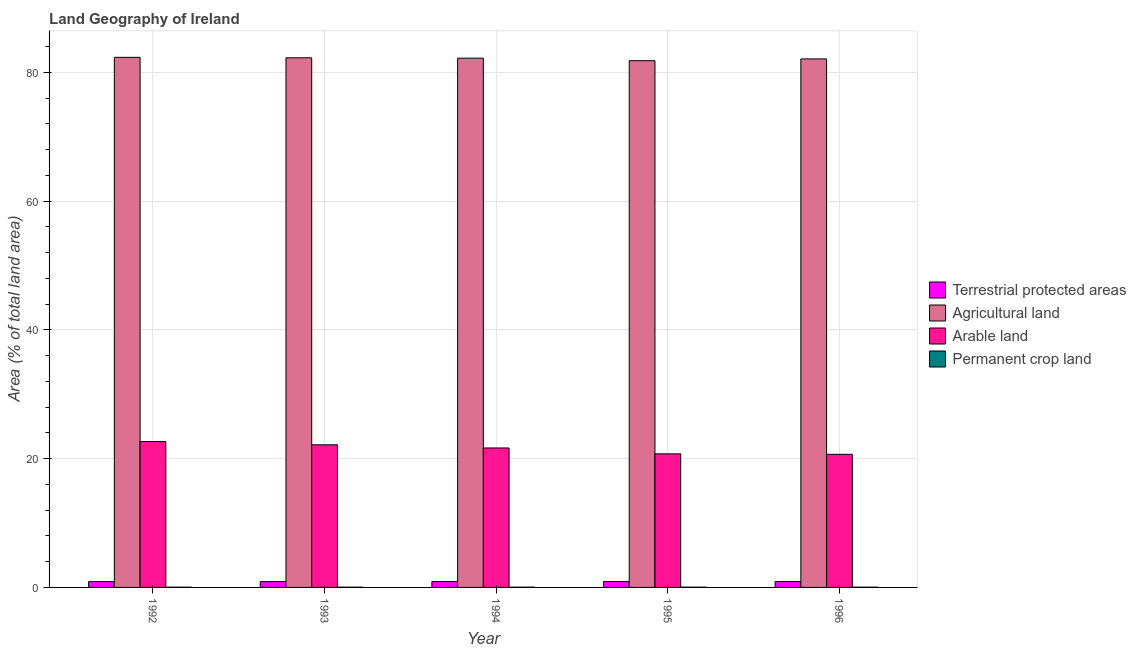Are the number of bars on each tick of the X-axis equal?
Your answer should be very brief. Yes. How many bars are there on the 2nd tick from the left?
Ensure brevity in your answer.  4. How many bars are there on the 3rd tick from the right?
Your answer should be very brief. 4. What is the label of the 3rd group of bars from the left?
Offer a very short reply. 1994. What is the percentage of area under arable land in 1995?
Your answer should be very brief. 20.74. Across all years, what is the maximum percentage of area under arable land?
Keep it short and to the point. 22.66. Across all years, what is the minimum percentage of area under agricultural land?
Make the answer very short. 81.8. In which year was the percentage of area under arable land maximum?
Provide a short and direct response. 1992. In which year was the percentage of area under arable land minimum?
Make the answer very short. 1996. What is the total percentage of area under arable land in the graph?
Provide a succinct answer. 107.88. What is the difference between the percentage of area under agricultural land in 1992 and that in 1994?
Ensure brevity in your answer.  0.13. What is the difference between the percentage of area under arable land in 1995 and the percentage of area under agricultural land in 1994?
Your response must be concise. -0.91. What is the average percentage of area under agricultural land per year?
Your answer should be compact. 82.13. What is the ratio of the percentage of area under arable land in 1992 to that in 1995?
Make the answer very short. 1.09. Is the percentage of area under arable land in 1992 less than that in 1995?
Provide a succinct answer. No. Is the difference between the percentage of area under permanent crop land in 1993 and 1996 greater than the difference between the percentage of land under terrestrial protection in 1993 and 1996?
Keep it short and to the point. No. What is the difference between the highest and the second highest percentage of area under agricultural land?
Your answer should be compact. 0.07. What is the difference between the highest and the lowest percentage of area under arable land?
Your response must be concise. 1.99. In how many years, is the percentage of area under permanent crop land greater than the average percentage of area under permanent crop land taken over all years?
Your answer should be compact. 0. Is it the case that in every year, the sum of the percentage of area under agricultural land and percentage of area under arable land is greater than the sum of percentage of land under terrestrial protection and percentage of area under permanent crop land?
Offer a terse response. Yes. What does the 3rd bar from the left in 1996 represents?
Provide a short and direct response. Arable land. What does the 4th bar from the right in 1992 represents?
Give a very brief answer. Terrestrial protected areas. Are all the bars in the graph horizontal?
Provide a succinct answer. No. How many years are there in the graph?
Keep it short and to the point. 5. What is the difference between two consecutive major ticks on the Y-axis?
Provide a short and direct response. 20. Are the values on the major ticks of Y-axis written in scientific E-notation?
Your answer should be compact. No. Does the graph contain any zero values?
Offer a very short reply. No. Does the graph contain grids?
Your answer should be compact. Yes. Where does the legend appear in the graph?
Provide a short and direct response. Center right. How are the legend labels stacked?
Give a very brief answer. Vertical. What is the title of the graph?
Offer a very short reply. Land Geography of Ireland. What is the label or title of the X-axis?
Your response must be concise. Year. What is the label or title of the Y-axis?
Offer a very short reply. Area (% of total land area). What is the Area (% of total land area) of Terrestrial protected areas in 1992?
Offer a very short reply. 0.9. What is the Area (% of total land area) of Agricultural land in 1992?
Provide a short and direct response. 82.32. What is the Area (% of total land area) of Arable land in 1992?
Your response must be concise. 22.66. What is the Area (% of total land area) in Permanent crop land in 1992?
Keep it short and to the point. 0.04. What is the Area (% of total land area) in Terrestrial protected areas in 1993?
Provide a short and direct response. 0.9. What is the Area (% of total land area) in Agricultural land in 1993?
Your answer should be compact. 82.25. What is the Area (% of total land area) in Arable land in 1993?
Keep it short and to the point. 22.15. What is the Area (% of total land area) of Permanent crop land in 1993?
Ensure brevity in your answer.  0.04. What is the Area (% of total land area) of Terrestrial protected areas in 1994?
Make the answer very short. 0.91. What is the Area (% of total land area) of Agricultural land in 1994?
Offer a terse response. 82.19. What is the Area (% of total land area) in Arable land in 1994?
Make the answer very short. 21.66. What is the Area (% of total land area) in Permanent crop land in 1994?
Keep it short and to the point. 0.04. What is the Area (% of total land area) of Terrestrial protected areas in 1995?
Ensure brevity in your answer.  0.91. What is the Area (% of total land area) in Agricultural land in 1995?
Give a very brief answer. 81.8. What is the Area (% of total land area) of Arable land in 1995?
Give a very brief answer. 20.74. What is the Area (% of total land area) of Permanent crop land in 1995?
Provide a succinct answer. 0.04. What is the Area (% of total land area) of Terrestrial protected areas in 1996?
Make the answer very short. 0.91. What is the Area (% of total land area) in Agricultural land in 1996?
Your answer should be very brief. 82.07. What is the Area (% of total land area) of Arable land in 1996?
Give a very brief answer. 20.67. What is the Area (% of total land area) in Permanent crop land in 1996?
Your answer should be very brief. 0.04. Across all years, what is the maximum Area (% of total land area) of Terrestrial protected areas?
Offer a terse response. 0.91. Across all years, what is the maximum Area (% of total land area) of Agricultural land?
Your answer should be compact. 82.32. Across all years, what is the maximum Area (% of total land area) in Arable land?
Provide a succinct answer. 22.66. Across all years, what is the maximum Area (% of total land area) of Permanent crop land?
Your response must be concise. 0.04. Across all years, what is the minimum Area (% of total land area) of Terrestrial protected areas?
Ensure brevity in your answer.  0.9. Across all years, what is the minimum Area (% of total land area) of Agricultural land?
Your answer should be compact. 81.8. Across all years, what is the minimum Area (% of total land area) in Arable land?
Keep it short and to the point. 20.67. Across all years, what is the minimum Area (% of total land area) in Permanent crop land?
Your response must be concise. 0.04. What is the total Area (% of total land area) of Terrestrial protected areas in the graph?
Your answer should be very brief. 4.53. What is the total Area (% of total land area) of Agricultural land in the graph?
Provide a succinct answer. 410.63. What is the total Area (% of total land area) of Arable land in the graph?
Your answer should be very brief. 107.88. What is the total Area (% of total land area) of Permanent crop land in the graph?
Provide a succinct answer. 0.22. What is the difference between the Area (% of total land area) of Terrestrial protected areas in 1992 and that in 1993?
Keep it short and to the point. -0. What is the difference between the Area (% of total land area) in Agricultural land in 1992 and that in 1993?
Your answer should be very brief. 0.07. What is the difference between the Area (% of total land area) in Arable land in 1992 and that in 1993?
Provide a succinct answer. 0.51. What is the difference between the Area (% of total land area) in Permanent crop land in 1992 and that in 1993?
Make the answer very short. 0. What is the difference between the Area (% of total land area) of Terrestrial protected areas in 1992 and that in 1994?
Your response must be concise. -0. What is the difference between the Area (% of total land area) of Agricultural land in 1992 and that in 1994?
Offer a very short reply. 0.13. What is the difference between the Area (% of total land area) of Permanent crop land in 1992 and that in 1994?
Your response must be concise. 0. What is the difference between the Area (% of total land area) in Terrestrial protected areas in 1992 and that in 1995?
Your answer should be compact. -0.01. What is the difference between the Area (% of total land area) of Agricultural land in 1992 and that in 1995?
Your answer should be very brief. 0.52. What is the difference between the Area (% of total land area) in Arable land in 1992 and that in 1995?
Make the answer very short. 1.92. What is the difference between the Area (% of total land area) in Terrestrial protected areas in 1992 and that in 1996?
Your answer should be compact. -0.01. What is the difference between the Area (% of total land area) of Agricultural land in 1992 and that in 1996?
Ensure brevity in your answer.  0.25. What is the difference between the Area (% of total land area) of Arable land in 1992 and that in 1996?
Your answer should be compact. 1.99. What is the difference between the Area (% of total land area) of Terrestrial protected areas in 1993 and that in 1994?
Ensure brevity in your answer.  -0. What is the difference between the Area (% of total land area) of Agricultural land in 1993 and that in 1994?
Your answer should be very brief. 0.06. What is the difference between the Area (% of total land area) of Arable land in 1993 and that in 1994?
Ensure brevity in your answer.  0.49. What is the difference between the Area (% of total land area) in Permanent crop land in 1993 and that in 1994?
Ensure brevity in your answer.  0. What is the difference between the Area (% of total land area) of Terrestrial protected areas in 1993 and that in 1995?
Your answer should be compact. -0. What is the difference between the Area (% of total land area) in Agricultural land in 1993 and that in 1995?
Make the answer very short. 0.45. What is the difference between the Area (% of total land area) in Arable land in 1993 and that in 1995?
Offer a terse response. 1.41. What is the difference between the Area (% of total land area) in Terrestrial protected areas in 1993 and that in 1996?
Give a very brief answer. -0.01. What is the difference between the Area (% of total land area) in Agricultural land in 1993 and that in 1996?
Offer a very short reply. 0.17. What is the difference between the Area (% of total land area) of Arable land in 1993 and that in 1996?
Your answer should be very brief. 1.48. What is the difference between the Area (% of total land area) of Permanent crop land in 1993 and that in 1996?
Offer a terse response. 0. What is the difference between the Area (% of total land area) of Terrestrial protected areas in 1994 and that in 1995?
Offer a very short reply. -0. What is the difference between the Area (% of total land area) in Agricultural land in 1994 and that in 1995?
Offer a terse response. 0.39. What is the difference between the Area (% of total land area) of Arable land in 1994 and that in 1995?
Ensure brevity in your answer.  0.91. What is the difference between the Area (% of total land area) in Terrestrial protected areas in 1994 and that in 1996?
Your response must be concise. -0. What is the difference between the Area (% of total land area) of Agricultural land in 1994 and that in 1996?
Provide a short and direct response. 0.12. What is the difference between the Area (% of total land area) in Arable land in 1994 and that in 1996?
Keep it short and to the point. 0.99. What is the difference between the Area (% of total land area) in Permanent crop land in 1994 and that in 1996?
Keep it short and to the point. 0. What is the difference between the Area (% of total land area) of Terrestrial protected areas in 1995 and that in 1996?
Offer a terse response. -0. What is the difference between the Area (% of total land area) in Agricultural land in 1995 and that in 1996?
Provide a succinct answer. -0.28. What is the difference between the Area (% of total land area) in Arable land in 1995 and that in 1996?
Provide a succinct answer. 0.07. What is the difference between the Area (% of total land area) of Permanent crop land in 1995 and that in 1996?
Provide a succinct answer. 0. What is the difference between the Area (% of total land area) of Terrestrial protected areas in 1992 and the Area (% of total land area) of Agricultural land in 1993?
Offer a terse response. -81.34. What is the difference between the Area (% of total land area) in Terrestrial protected areas in 1992 and the Area (% of total land area) in Arable land in 1993?
Offer a very short reply. -21.25. What is the difference between the Area (% of total land area) in Terrestrial protected areas in 1992 and the Area (% of total land area) in Permanent crop land in 1993?
Provide a short and direct response. 0.86. What is the difference between the Area (% of total land area) in Agricultural land in 1992 and the Area (% of total land area) in Arable land in 1993?
Your response must be concise. 60.17. What is the difference between the Area (% of total land area) in Agricultural land in 1992 and the Area (% of total land area) in Permanent crop land in 1993?
Offer a terse response. 82.28. What is the difference between the Area (% of total land area) of Arable land in 1992 and the Area (% of total land area) of Permanent crop land in 1993?
Make the answer very short. 22.62. What is the difference between the Area (% of total land area) in Terrestrial protected areas in 1992 and the Area (% of total land area) in Agricultural land in 1994?
Offer a terse response. -81.29. What is the difference between the Area (% of total land area) of Terrestrial protected areas in 1992 and the Area (% of total land area) of Arable land in 1994?
Your answer should be compact. -20.76. What is the difference between the Area (% of total land area) in Terrestrial protected areas in 1992 and the Area (% of total land area) in Permanent crop land in 1994?
Give a very brief answer. 0.86. What is the difference between the Area (% of total land area) of Agricultural land in 1992 and the Area (% of total land area) of Arable land in 1994?
Offer a terse response. 60.66. What is the difference between the Area (% of total land area) of Agricultural land in 1992 and the Area (% of total land area) of Permanent crop land in 1994?
Ensure brevity in your answer.  82.28. What is the difference between the Area (% of total land area) of Arable land in 1992 and the Area (% of total land area) of Permanent crop land in 1994?
Make the answer very short. 22.62. What is the difference between the Area (% of total land area) in Terrestrial protected areas in 1992 and the Area (% of total land area) in Agricultural land in 1995?
Ensure brevity in your answer.  -80.89. What is the difference between the Area (% of total land area) of Terrestrial protected areas in 1992 and the Area (% of total land area) of Arable land in 1995?
Your response must be concise. -19.84. What is the difference between the Area (% of total land area) in Terrestrial protected areas in 1992 and the Area (% of total land area) in Permanent crop land in 1995?
Provide a short and direct response. 0.86. What is the difference between the Area (% of total land area) in Agricultural land in 1992 and the Area (% of total land area) in Arable land in 1995?
Make the answer very short. 61.58. What is the difference between the Area (% of total land area) of Agricultural land in 1992 and the Area (% of total land area) of Permanent crop land in 1995?
Provide a short and direct response. 82.28. What is the difference between the Area (% of total land area) in Arable land in 1992 and the Area (% of total land area) in Permanent crop land in 1995?
Provide a short and direct response. 22.62. What is the difference between the Area (% of total land area) in Terrestrial protected areas in 1992 and the Area (% of total land area) in Agricultural land in 1996?
Offer a terse response. -81.17. What is the difference between the Area (% of total land area) of Terrestrial protected areas in 1992 and the Area (% of total land area) of Arable land in 1996?
Provide a short and direct response. -19.77. What is the difference between the Area (% of total land area) in Terrestrial protected areas in 1992 and the Area (% of total land area) in Permanent crop land in 1996?
Your response must be concise. 0.86. What is the difference between the Area (% of total land area) in Agricultural land in 1992 and the Area (% of total land area) in Arable land in 1996?
Ensure brevity in your answer.  61.65. What is the difference between the Area (% of total land area) of Agricultural land in 1992 and the Area (% of total land area) of Permanent crop land in 1996?
Give a very brief answer. 82.28. What is the difference between the Area (% of total land area) in Arable land in 1992 and the Area (% of total land area) in Permanent crop land in 1996?
Keep it short and to the point. 22.62. What is the difference between the Area (% of total land area) in Terrestrial protected areas in 1993 and the Area (% of total land area) in Agricultural land in 1994?
Offer a very short reply. -81.29. What is the difference between the Area (% of total land area) of Terrestrial protected areas in 1993 and the Area (% of total land area) of Arable land in 1994?
Give a very brief answer. -20.75. What is the difference between the Area (% of total land area) in Terrestrial protected areas in 1993 and the Area (% of total land area) in Permanent crop land in 1994?
Offer a very short reply. 0.86. What is the difference between the Area (% of total land area) of Agricultural land in 1993 and the Area (% of total land area) of Arable land in 1994?
Ensure brevity in your answer.  60.59. What is the difference between the Area (% of total land area) in Agricultural land in 1993 and the Area (% of total land area) in Permanent crop land in 1994?
Your response must be concise. 82.2. What is the difference between the Area (% of total land area) in Arable land in 1993 and the Area (% of total land area) in Permanent crop land in 1994?
Your answer should be compact. 22.11. What is the difference between the Area (% of total land area) of Terrestrial protected areas in 1993 and the Area (% of total land area) of Agricultural land in 1995?
Your response must be concise. -80.89. What is the difference between the Area (% of total land area) in Terrestrial protected areas in 1993 and the Area (% of total land area) in Arable land in 1995?
Your answer should be very brief. -19.84. What is the difference between the Area (% of total land area) of Terrestrial protected areas in 1993 and the Area (% of total land area) of Permanent crop land in 1995?
Your answer should be compact. 0.86. What is the difference between the Area (% of total land area) of Agricultural land in 1993 and the Area (% of total land area) of Arable land in 1995?
Your answer should be very brief. 61.5. What is the difference between the Area (% of total land area) of Agricultural land in 1993 and the Area (% of total land area) of Permanent crop land in 1995?
Make the answer very short. 82.2. What is the difference between the Area (% of total land area) of Arable land in 1993 and the Area (% of total land area) of Permanent crop land in 1995?
Give a very brief answer. 22.11. What is the difference between the Area (% of total land area) in Terrestrial protected areas in 1993 and the Area (% of total land area) in Agricultural land in 1996?
Give a very brief answer. -81.17. What is the difference between the Area (% of total land area) in Terrestrial protected areas in 1993 and the Area (% of total land area) in Arable land in 1996?
Offer a very short reply. -19.77. What is the difference between the Area (% of total land area) of Terrestrial protected areas in 1993 and the Area (% of total land area) of Permanent crop land in 1996?
Offer a very short reply. 0.86. What is the difference between the Area (% of total land area) in Agricultural land in 1993 and the Area (% of total land area) in Arable land in 1996?
Keep it short and to the point. 61.58. What is the difference between the Area (% of total land area) of Agricultural land in 1993 and the Area (% of total land area) of Permanent crop land in 1996?
Ensure brevity in your answer.  82.2. What is the difference between the Area (% of total land area) in Arable land in 1993 and the Area (% of total land area) in Permanent crop land in 1996?
Provide a short and direct response. 22.11. What is the difference between the Area (% of total land area) of Terrestrial protected areas in 1994 and the Area (% of total land area) of Agricultural land in 1995?
Provide a succinct answer. -80.89. What is the difference between the Area (% of total land area) in Terrestrial protected areas in 1994 and the Area (% of total land area) in Arable land in 1995?
Provide a succinct answer. -19.84. What is the difference between the Area (% of total land area) in Terrestrial protected areas in 1994 and the Area (% of total land area) in Permanent crop land in 1995?
Offer a very short reply. 0.86. What is the difference between the Area (% of total land area) of Agricultural land in 1994 and the Area (% of total land area) of Arable land in 1995?
Offer a terse response. 61.45. What is the difference between the Area (% of total land area) in Agricultural land in 1994 and the Area (% of total land area) in Permanent crop land in 1995?
Your answer should be compact. 82.15. What is the difference between the Area (% of total land area) in Arable land in 1994 and the Area (% of total land area) in Permanent crop land in 1995?
Offer a very short reply. 21.61. What is the difference between the Area (% of total land area) in Terrestrial protected areas in 1994 and the Area (% of total land area) in Agricultural land in 1996?
Keep it short and to the point. -81.17. What is the difference between the Area (% of total land area) of Terrestrial protected areas in 1994 and the Area (% of total land area) of Arable land in 1996?
Your answer should be compact. -19.76. What is the difference between the Area (% of total land area) of Terrestrial protected areas in 1994 and the Area (% of total land area) of Permanent crop land in 1996?
Provide a short and direct response. 0.86. What is the difference between the Area (% of total land area) of Agricultural land in 1994 and the Area (% of total land area) of Arable land in 1996?
Provide a succinct answer. 61.52. What is the difference between the Area (% of total land area) of Agricultural land in 1994 and the Area (% of total land area) of Permanent crop land in 1996?
Your answer should be compact. 82.15. What is the difference between the Area (% of total land area) of Arable land in 1994 and the Area (% of total land area) of Permanent crop land in 1996?
Ensure brevity in your answer.  21.61. What is the difference between the Area (% of total land area) of Terrestrial protected areas in 1995 and the Area (% of total land area) of Agricultural land in 1996?
Keep it short and to the point. -81.17. What is the difference between the Area (% of total land area) of Terrestrial protected areas in 1995 and the Area (% of total land area) of Arable land in 1996?
Your response must be concise. -19.76. What is the difference between the Area (% of total land area) of Terrestrial protected areas in 1995 and the Area (% of total land area) of Permanent crop land in 1996?
Your answer should be very brief. 0.86. What is the difference between the Area (% of total land area) in Agricultural land in 1995 and the Area (% of total land area) in Arable land in 1996?
Ensure brevity in your answer.  61.13. What is the difference between the Area (% of total land area) of Agricultural land in 1995 and the Area (% of total land area) of Permanent crop land in 1996?
Your answer should be very brief. 81.75. What is the difference between the Area (% of total land area) in Arable land in 1995 and the Area (% of total land area) in Permanent crop land in 1996?
Make the answer very short. 20.7. What is the average Area (% of total land area) of Terrestrial protected areas per year?
Offer a terse response. 0.91. What is the average Area (% of total land area) of Agricultural land per year?
Your response must be concise. 82.13. What is the average Area (% of total land area) in Arable land per year?
Ensure brevity in your answer.  21.58. What is the average Area (% of total land area) in Permanent crop land per year?
Offer a very short reply. 0.04. In the year 1992, what is the difference between the Area (% of total land area) of Terrestrial protected areas and Area (% of total land area) of Agricultural land?
Offer a terse response. -81.42. In the year 1992, what is the difference between the Area (% of total land area) in Terrestrial protected areas and Area (% of total land area) in Arable land?
Provide a short and direct response. -21.76. In the year 1992, what is the difference between the Area (% of total land area) in Terrestrial protected areas and Area (% of total land area) in Permanent crop land?
Make the answer very short. 0.86. In the year 1992, what is the difference between the Area (% of total land area) of Agricultural land and Area (% of total land area) of Arable land?
Offer a very short reply. 59.66. In the year 1992, what is the difference between the Area (% of total land area) of Agricultural land and Area (% of total land area) of Permanent crop land?
Give a very brief answer. 82.28. In the year 1992, what is the difference between the Area (% of total land area) in Arable land and Area (% of total land area) in Permanent crop land?
Make the answer very short. 22.62. In the year 1993, what is the difference between the Area (% of total land area) of Terrestrial protected areas and Area (% of total land area) of Agricultural land?
Your response must be concise. -81.34. In the year 1993, what is the difference between the Area (% of total land area) in Terrestrial protected areas and Area (% of total land area) in Arable land?
Your response must be concise. -21.25. In the year 1993, what is the difference between the Area (% of total land area) of Terrestrial protected areas and Area (% of total land area) of Permanent crop land?
Make the answer very short. 0.86. In the year 1993, what is the difference between the Area (% of total land area) in Agricultural land and Area (% of total land area) in Arable land?
Keep it short and to the point. 60.1. In the year 1993, what is the difference between the Area (% of total land area) of Agricultural land and Area (% of total land area) of Permanent crop land?
Ensure brevity in your answer.  82.2. In the year 1993, what is the difference between the Area (% of total land area) in Arable land and Area (% of total land area) in Permanent crop land?
Make the answer very short. 22.11. In the year 1994, what is the difference between the Area (% of total land area) of Terrestrial protected areas and Area (% of total land area) of Agricultural land?
Give a very brief answer. -81.28. In the year 1994, what is the difference between the Area (% of total land area) in Terrestrial protected areas and Area (% of total land area) in Arable land?
Offer a very short reply. -20.75. In the year 1994, what is the difference between the Area (% of total land area) in Terrestrial protected areas and Area (% of total land area) in Permanent crop land?
Give a very brief answer. 0.86. In the year 1994, what is the difference between the Area (% of total land area) in Agricultural land and Area (% of total land area) in Arable land?
Make the answer very short. 60.53. In the year 1994, what is the difference between the Area (% of total land area) of Agricultural land and Area (% of total land area) of Permanent crop land?
Give a very brief answer. 82.15. In the year 1994, what is the difference between the Area (% of total land area) of Arable land and Area (% of total land area) of Permanent crop land?
Offer a very short reply. 21.61. In the year 1995, what is the difference between the Area (% of total land area) of Terrestrial protected areas and Area (% of total land area) of Agricultural land?
Ensure brevity in your answer.  -80.89. In the year 1995, what is the difference between the Area (% of total land area) in Terrestrial protected areas and Area (% of total land area) in Arable land?
Provide a succinct answer. -19.84. In the year 1995, what is the difference between the Area (% of total land area) in Terrestrial protected areas and Area (% of total land area) in Permanent crop land?
Your response must be concise. 0.86. In the year 1995, what is the difference between the Area (% of total land area) of Agricultural land and Area (% of total land area) of Arable land?
Offer a terse response. 61.05. In the year 1995, what is the difference between the Area (% of total land area) in Agricultural land and Area (% of total land area) in Permanent crop land?
Your response must be concise. 81.75. In the year 1995, what is the difference between the Area (% of total land area) of Arable land and Area (% of total land area) of Permanent crop land?
Provide a succinct answer. 20.7. In the year 1996, what is the difference between the Area (% of total land area) of Terrestrial protected areas and Area (% of total land area) of Agricultural land?
Provide a succinct answer. -81.17. In the year 1996, what is the difference between the Area (% of total land area) in Terrestrial protected areas and Area (% of total land area) in Arable land?
Give a very brief answer. -19.76. In the year 1996, what is the difference between the Area (% of total land area) in Terrestrial protected areas and Area (% of total land area) in Permanent crop land?
Your answer should be compact. 0.86. In the year 1996, what is the difference between the Area (% of total land area) in Agricultural land and Area (% of total land area) in Arable land?
Provide a succinct answer. 61.4. In the year 1996, what is the difference between the Area (% of total land area) of Agricultural land and Area (% of total land area) of Permanent crop land?
Offer a terse response. 82.03. In the year 1996, what is the difference between the Area (% of total land area) in Arable land and Area (% of total land area) in Permanent crop land?
Ensure brevity in your answer.  20.63. What is the ratio of the Area (% of total land area) of Terrestrial protected areas in 1992 to that in 1993?
Offer a very short reply. 1. What is the ratio of the Area (% of total land area) of Agricultural land in 1992 to that in 1993?
Your response must be concise. 1. What is the ratio of the Area (% of total land area) in Arable land in 1992 to that in 1993?
Give a very brief answer. 1.02. What is the ratio of the Area (% of total land area) of Permanent crop land in 1992 to that in 1993?
Keep it short and to the point. 1. What is the ratio of the Area (% of total land area) in Terrestrial protected areas in 1992 to that in 1994?
Ensure brevity in your answer.  1. What is the ratio of the Area (% of total land area) of Arable land in 1992 to that in 1994?
Your answer should be very brief. 1.05. What is the ratio of the Area (% of total land area) of Permanent crop land in 1992 to that in 1994?
Provide a succinct answer. 1. What is the ratio of the Area (% of total land area) in Terrestrial protected areas in 1992 to that in 1995?
Provide a short and direct response. 0.99. What is the ratio of the Area (% of total land area) in Agricultural land in 1992 to that in 1995?
Offer a terse response. 1.01. What is the ratio of the Area (% of total land area) in Arable land in 1992 to that in 1995?
Your answer should be compact. 1.09. What is the ratio of the Area (% of total land area) in Permanent crop land in 1992 to that in 1995?
Keep it short and to the point. 1. What is the ratio of the Area (% of total land area) of Terrestrial protected areas in 1992 to that in 1996?
Give a very brief answer. 0.99. What is the ratio of the Area (% of total land area) in Agricultural land in 1992 to that in 1996?
Give a very brief answer. 1. What is the ratio of the Area (% of total land area) of Arable land in 1992 to that in 1996?
Ensure brevity in your answer.  1.1. What is the ratio of the Area (% of total land area) in Permanent crop land in 1992 to that in 1996?
Provide a short and direct response. 1. What is the ratio of the Area (% of total land area) in Arable land in 1993 to that in 1994?
Ensure brevity in your answer.  1.02. What is the ratio of the Area (% of total land area) of Permanent crop land in 1993 to that in 1994?
Give a very brief answer. 1. What is the ratio of the Area (% of total land area) in Agricultural land in 1993 to that in 1995?
Offer a terse response. 1.01. What is the ratio of the Area (% of total land area) in Arable land in 1993 to that in 1995?
Ensure brevity in your answer.  1.07. What is the ratio of the Area (% of total land area) of Terrestrial protected areas in 1993 to that in 1996?
Provide a succinct answer. 0.99. What is the ratio of the Area (% of total land area) in Agricultural land in 1993 to that in 1996?
Provide a succinct answer. 1. What is the ratio of the Area (% of total land area) of Arable land in 1993 to that in 1996?
Keep it short and to the point. 1.07. What is the ratio of the Area (% of total land area) of Permanent crop land in 1993 to that in 1996?
Your answer should be compact. 1. What is the ratio of the Area (% of total land area) in Arable land in 1994 to that in 1995?
Your answer should be compact. 1.04. What is the ratio of the Area (% of total land area) of Terrestrial protected areas in 1994 to that in 1996?
Provide a succinct answer. 1. What is the ratio of the Area (% of total land area) of Arable land in 1994 to that in 1996?
Keep it short and to the point. 1.05. What is the ratio of the Area (% of total land area) in Permanent crop land in 1994 to that in 1996?
Provide a succinct answer. 1. What is the ratio of the Area (% of total land area) of Agricultural land in 1995 to that in 1996?
Ensure brevity in your answer.  1. What is the ratio of the Area (% of total land area) of Permanent crop land in 1995 to that in 1996?
Your response must be concise. 1. What is the difference between the highest and the second highest Area (% of total land area) in Agricultural land?
Your answer should be very brief. 0.07. What is the difference between the highest and the second highest Area (% of total land area) in Arable land?
Your answer should be compact. 0.51. What is the difference between the highest and the lowest Area (% of total land area) of Terrestrial protected areas?
Your answer should be very brief. 0.01. What is the difference between the highest and the lowest Area (% of total land area) in Agricultural land?
Your response must be concise. 0.52. What is the difference between the highest and the lowest Area (% of total land area) in Arable land?
Ensure brevity in your answer.  1.99. What is the difference between the highest and the lowest Area (% of total land area) in Permanent crop land?
Keep it short and to the point. 0. 